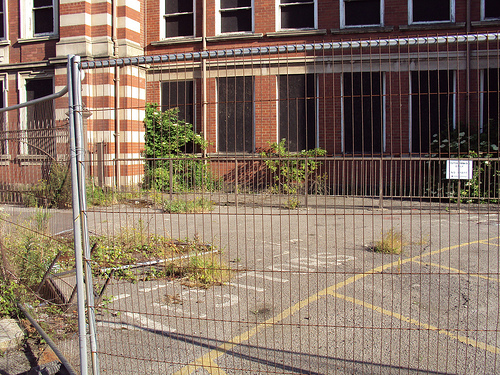<image>
Is there a sign behind the fence? Yes. From this viewpoint, the sign is positioned behind the fence, with the fence partially or fully occluding the sign. 